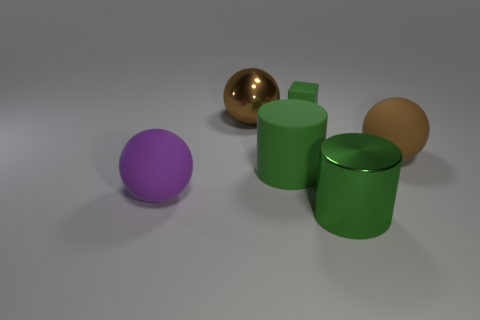What is the material of the other big cylinder that is the same color as the large rubber cylinder?
Your answer should be compact. Metal. There is a purple sphere; are there any big green objects behind it?
Give a very brief answer. Yes. Is the number of large green metal objects greater than the number of big things?
Provide a succinct answer. No. There is a matte object that is on the right side of the large shiny thing that is in front of the big brown sphere to the left of the large brown matte sphere; what is its color?
Ensure brevity in your answer.  Brown. There is a cylinder that is made of the same material as the block; what is its color?
Provide a short and direct response. Green. Are there any other things that are the same size as the rubber cube?
Your response must be concise. No. How many objects are either big brown things right of the tiny block or large balls that are right of the big green metallic object?
Offer a very short reply. 1. There is a brown sphere on the left side of the big matte cylinder; is its size the same as the brown object that is in front of the brown metal thing?
Offer a very short reply. Yes. There is another metallic object that is the same shape as the big purple object; what is its color?
Ensure brevity in your answer.  Brown. Is there any other thing that has the same shape as the tiny green matte thing?
Ensure brevity in your answer.  No. 